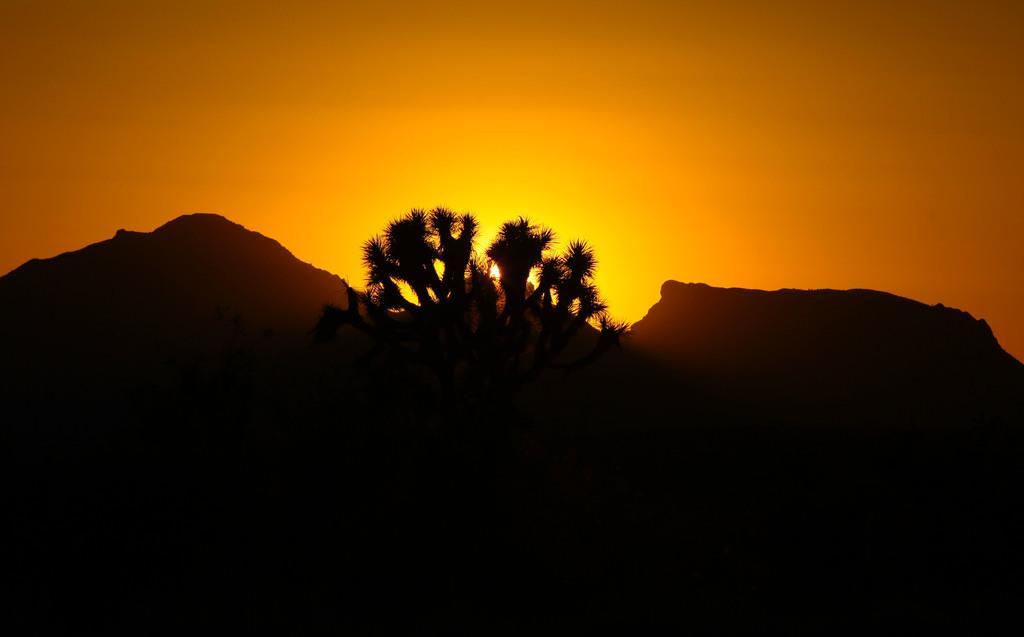Describe this image in one or two sentences. In this image I can see few trees and mountains. In the background I can see the sun and the sky is in orange and yellow color. 